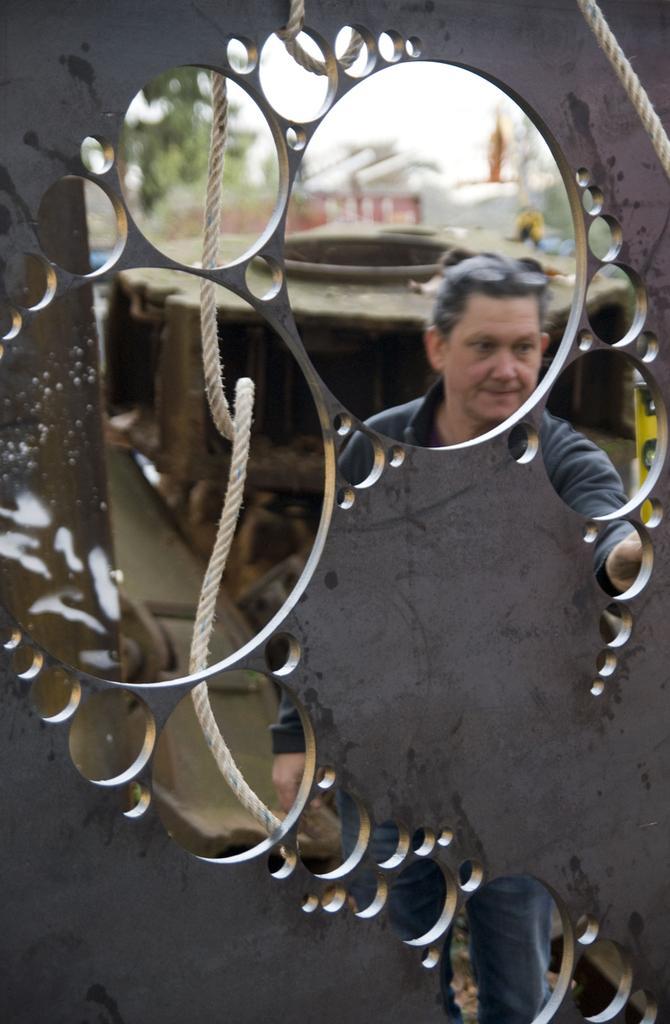How would you summarize this image in a sentence or two? In this picture there is a man standing behind the metal object and there is a rope. At the back there are objects and there are trees and their might be a vehicle. At the top there is sky. 